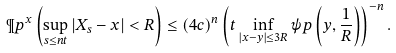Convert formula to latex. <formula><loc_0><loc_0><loc_500><loc_500>\P p ^ { x } \left ( \sup _ { s \leq n t } | X _ { s } - x | < R \right ) \leq ( 4 c ) ^ { n } \left ( t \inf _ { | x - y | \leq 3 R } \psi p \left ( y , \frac { 1 } { R } \right ) \right ) ^ { - n } .</formula> 